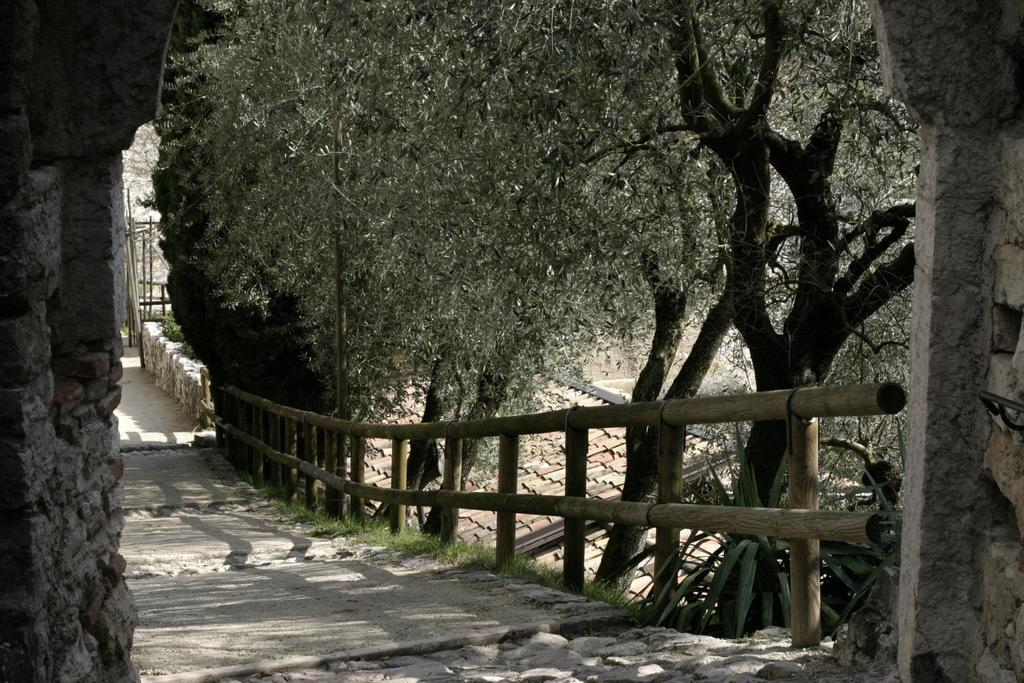What type of structure can be seen in the image? There is an arch in the image. What other architectural feature is present in the image? There is a walkway bridge in the image. What can be seen in the background of the image? There are trees and a shed in the background of the image. What type of flowers can be seen growing on the arch in the image? There are no flowers growing on the arch in the image. 